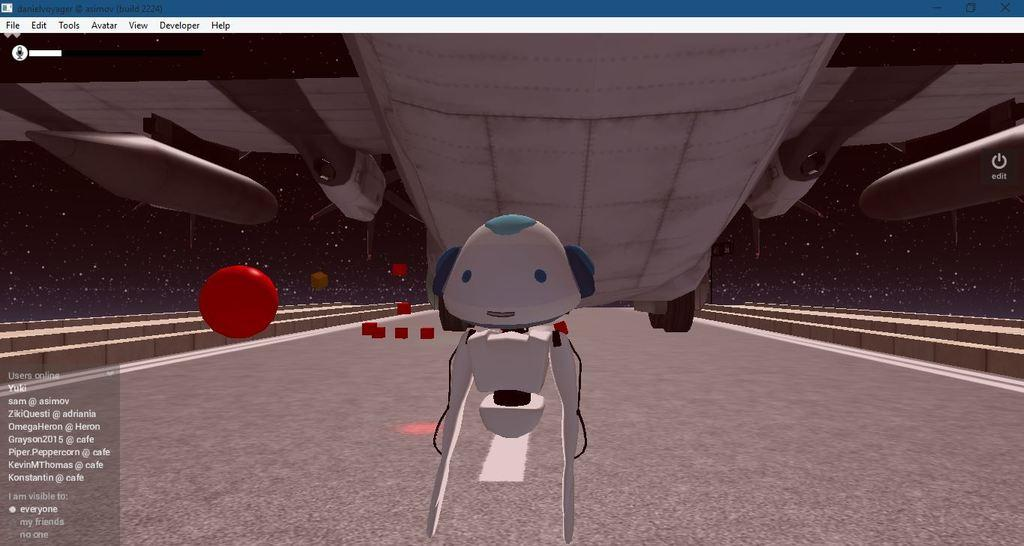What is the main subject of the image? The main subject of the image is a computer screen. What is depicted on the screen? There is an anime robot on the road in the image. What is flying above the robot? There is a plane above the robot in the image. Where is the text located in the image? The text is on the left side of the image. What type of patch is being sewn onto the robot's arm in the image? There is no patch being sewn onto the robot's arm in the image; it is an anime robot on a computer screen. What record is being played in the background of the image? There is no record being played in the background of the image; it is a still image of a computer screen. 